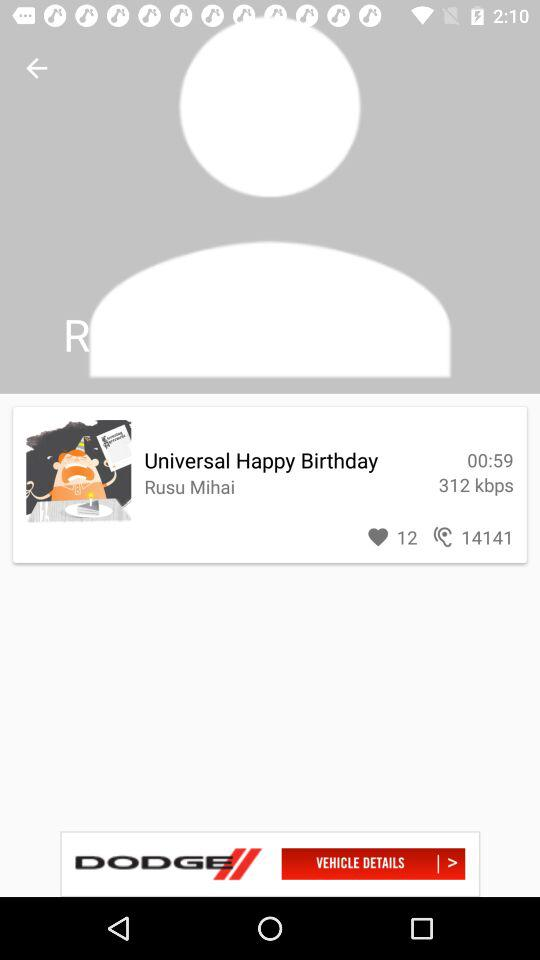What is the duration of "Universal Happy Birthday"? The duration is 59 seconds. 